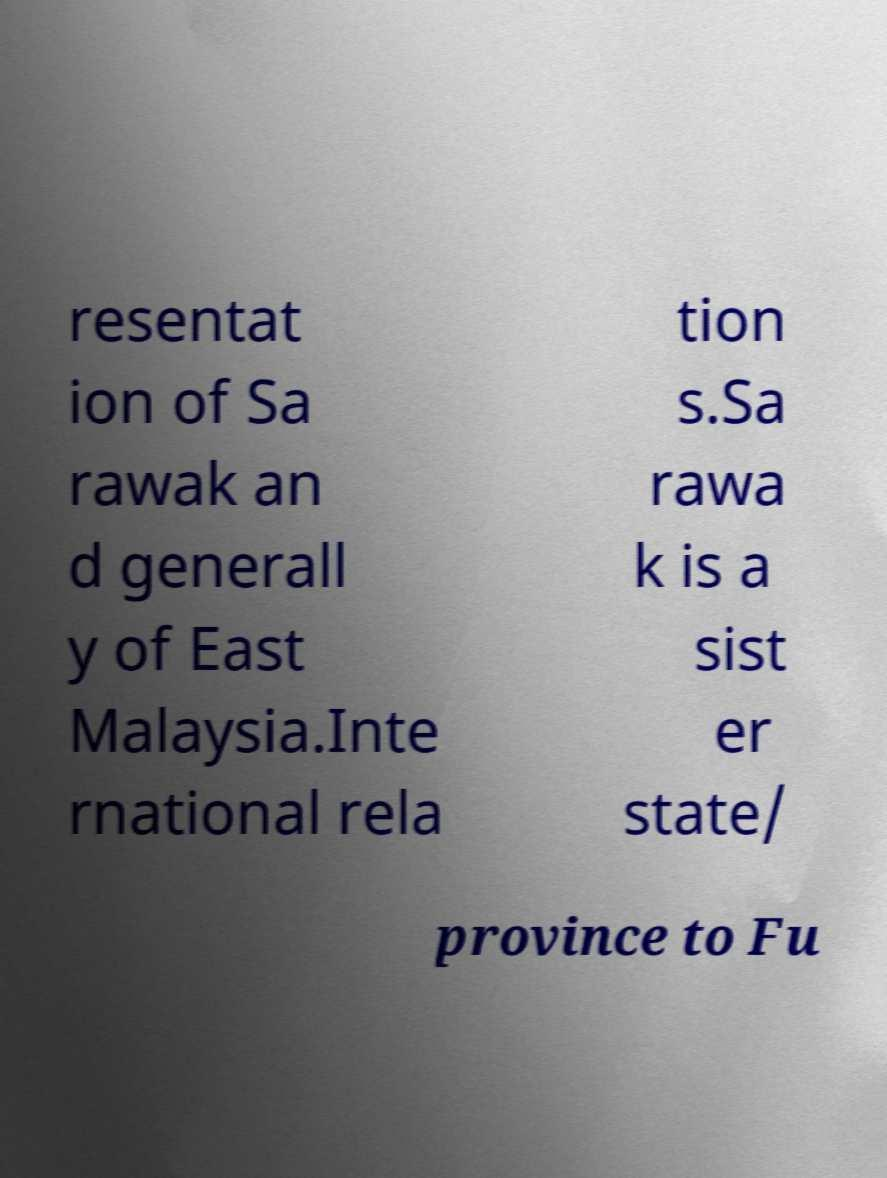What messages or text are displayed in this image? I need them in a readable, typed format. resentat ion of Sa rawak an d generall y of East Malaysia.Inte rnational rela tion s.Sa rawa k is a sist er state/ province to Fu 